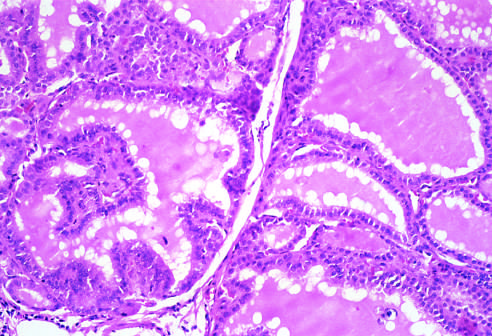re apoptotic cells lined by tall columnar epithelial cells that are actively resorbing the colloid in the centers of the follicles, resulting in a scalloped appearance of the colloid?
Answer the question using a single word or phrase. No 